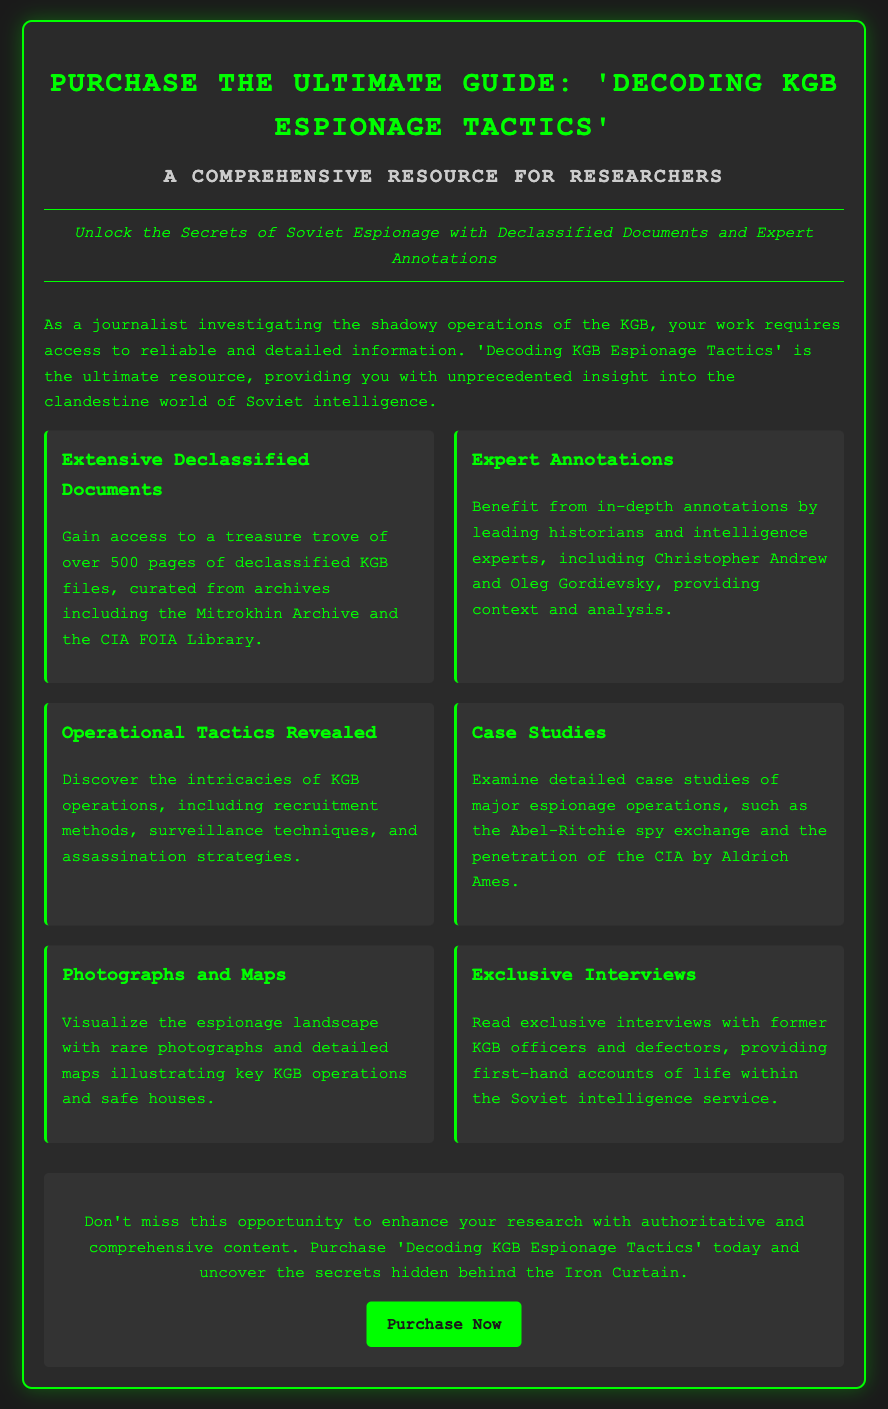What is the title of the guide? The title is specifically stated in the document as "Decoding KGB Espionage Tactics."
Answer: Decoding KGB Espionage Tactics How many pages of declassified KGB files are included? The document mentions "over 500 pages" of declassified KGB files.
Answer: over 500 pages Who authored the expert annotations? The document lists Christopher Andrew and Oleg Gordievsky as the historians providing expert annotations.
Answer: Christopher Andrew and Oleg Gordievsky What type of case studies are examined? The document refers to major espionage operations, such as the Abel-Ritchie spy exchange.
Answer: major espionage operations What type of exclusive content is mentioned? The document states that there are exclusive interviews with former KGB officers and defectors.
Answer: exclusive interviews What is the background color of the body in the advertisement? The document indicates the body has a background color of "#1a1a1a."
Answer: #1a1a1a What is the color of the border around the container? The color of the border is explicitly stated as "#00ff00."
Answer: #00ff00 What is the purpose of the guide? The guide is intended to provide researchers with insight into the clandestine world of Soviet intelligence.
Answer: insight into the clandestine world of Soviet intelligence 